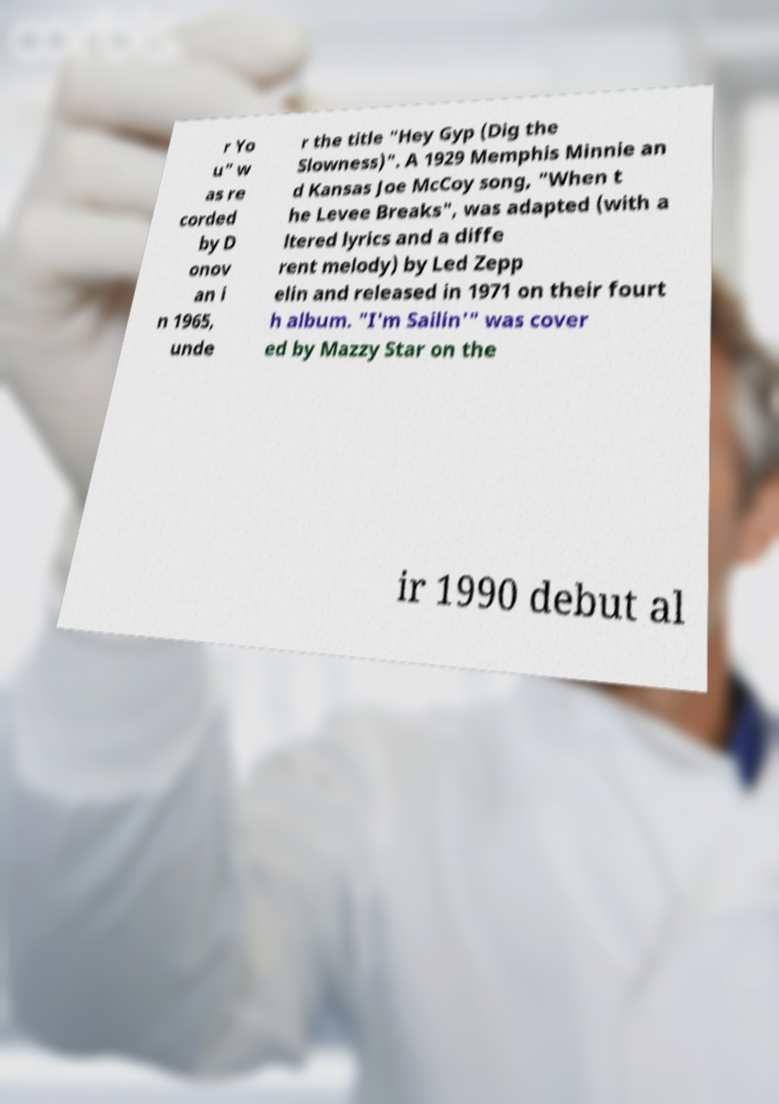Please read and relay the text visible in this image. What does it say? r Yo u" w as re corded by D onov an i n 1965, unde r the title "Hey Gyp (Dig the Slowness)". A 1929 Memphis Minnie an d Kansas Joe McCoy song, "When t he Levee Breaks", was adapted (with a ltered lyrics and a diffe rent melody) by Led Zepp elin and released in 1971 on their fourt h album. "I'm Sailin'" was cover ed by Mazzy Star on the ir 1990 debut al 